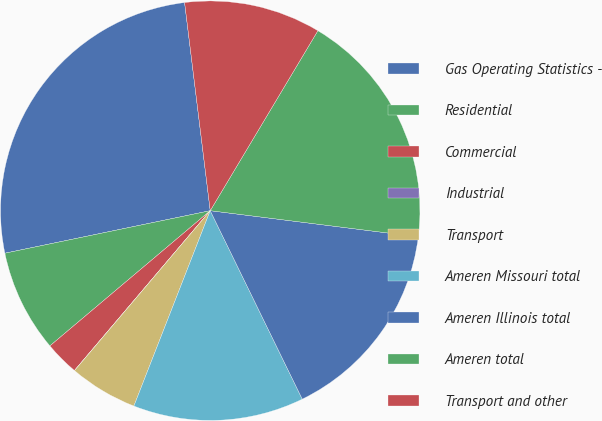Convert chart. <chart><loc_0><loc_0><loc_500><loc_500><pie_chart><fcel>Gas Operating Statistics -<fcel>Residential<fcel>Commercial<fcel>Industrial<fcel>Transport<fcel>Ameren Missouri total<fcel>Ameren Illinois total<fcel>Ameren total<fcel>Transport and other<nl><fcel>26.3%<fcel>7.9%<fcel>2.64%<fcel>0.01%<fcel>5.27%<fcel>13.16%<fcel>15.78%<fcel>18.41%<fcel>10.53%<nl></chart> 